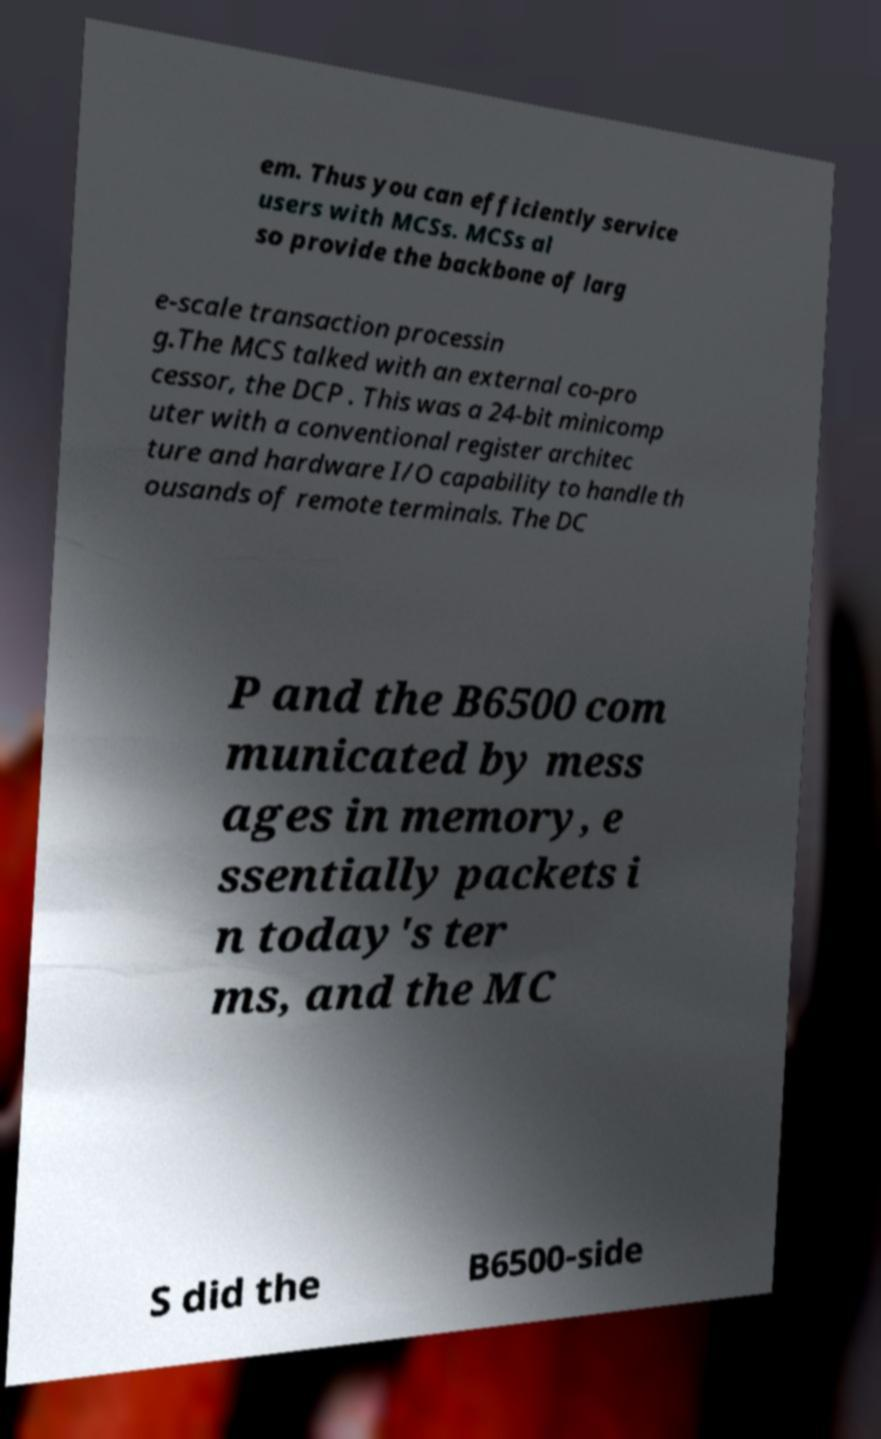Please identify and transcribe the text found in this image. em. Thus you can efficiently service users with MCSs. MCSs al so provide the backbone of larg e-scale transaction processin g.The MCS talked with an external co-pro cessor, the DCP . This was a 24-bit minicomp uter with a conventional register architec ture and hardware I/O capability to handle th ousands of remote terminals. The DC P and the B6500 com municated by mess ages in memory, e ssentially packets i n today's ter ms, and the MC S did the B6500-side 